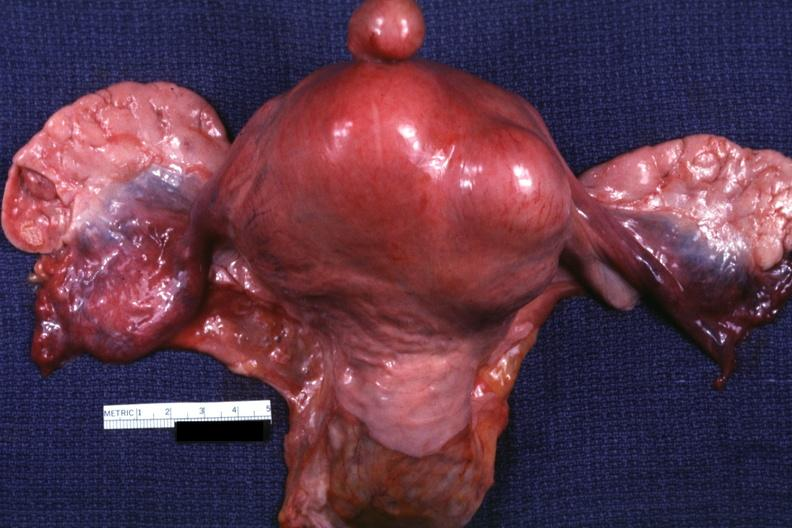what does this image show?
Answer the question using a single word or phrase. Unopened uterus tubes and ovaries 